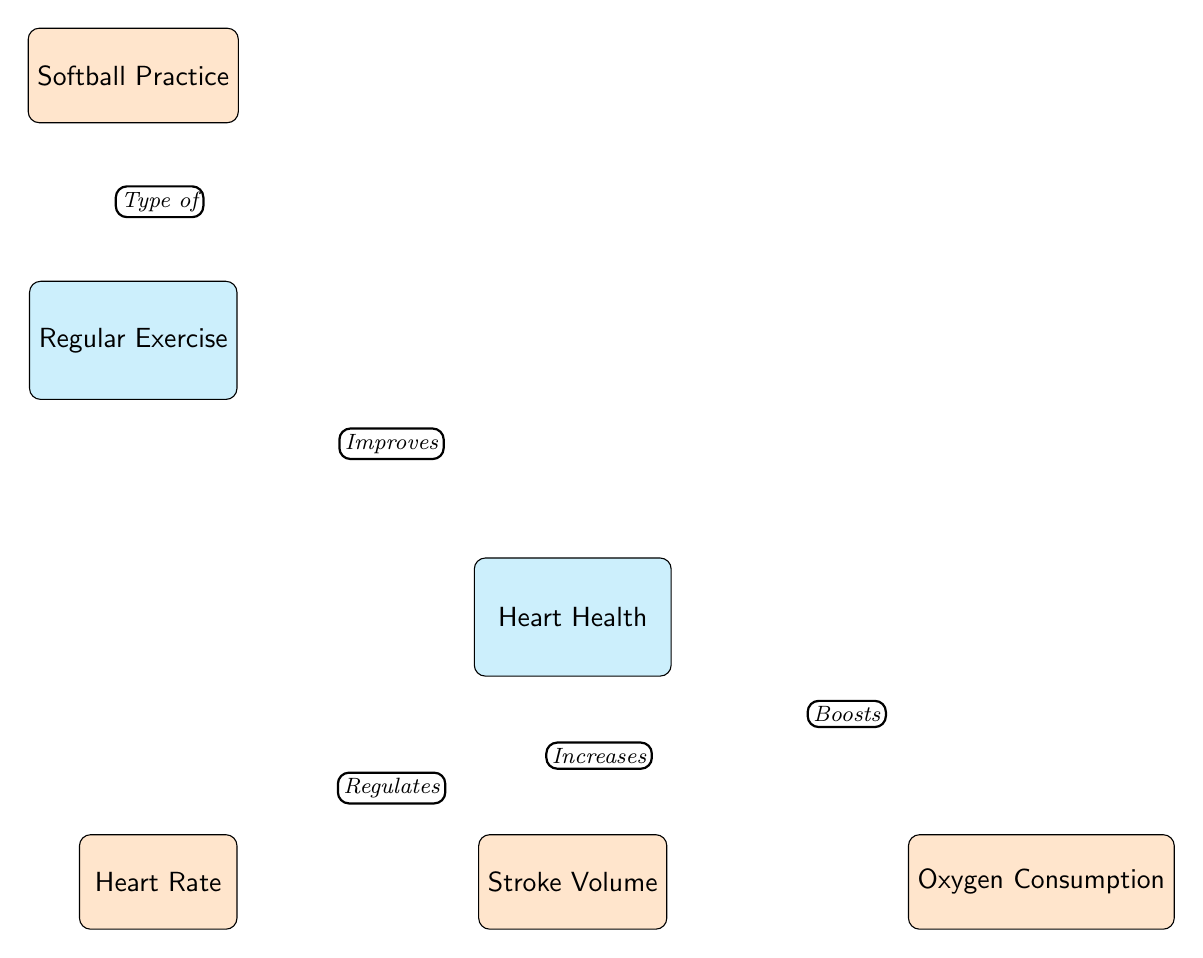What is the main focus of this diagram? The diagram centers around "Heart Health" as the primary theme, indicated by the central node labeled with this phrase.
Answer: Heart Health What type of exercise is specifically mentioned in the diagram? The diagram includes "Softball Practice" as a specific activity that falls under the broader category of regular exercise.
Answer: Softball Practice How does regular exercise relate to heart health? A direct connection is shown from "Regular Exercise" to "Heart Health," indicating that regular exercise improves heart health.
Answer: Improves Which node indicates the effect of heart health on heart rate? The diagram indicates that "Heart Health" regulates "Heart Rate," establishing a direct influence flowing from heart health to this metric.
Answer: Regulates What is the relationship between heart health and stroke volume? The relationship is depicted as an increase, marking a direct link that demonstrates how heart health enhances stroke volume.
Answer: Increases How many direct influences are depicted in the diagram? The diagram shows four direct influences stemming from the "Heart Health" node, including heart rate, stroke volume, and oxygen consumption.
Answer: Four What does the heart health node boost according to the diagram? The diagram specifically states that heart health boosts "Oxygen Consumption," indicating a positive effect on this aspect of cardiovascular health.
Answer: Boosts What type of exercise contributes to heart health according to the diagram? Regular exercise is understood as the contributing factor to heart health, as shown in the diagram.
Answer: Regular Exercise What aspect of cardiovascular health does softball practice influence? The diagram implies that softball practice affects heart health through its classification as a form of regular exercise, indirectly promoting various cardiovascular metrics.
Answer: Regular Exercise 